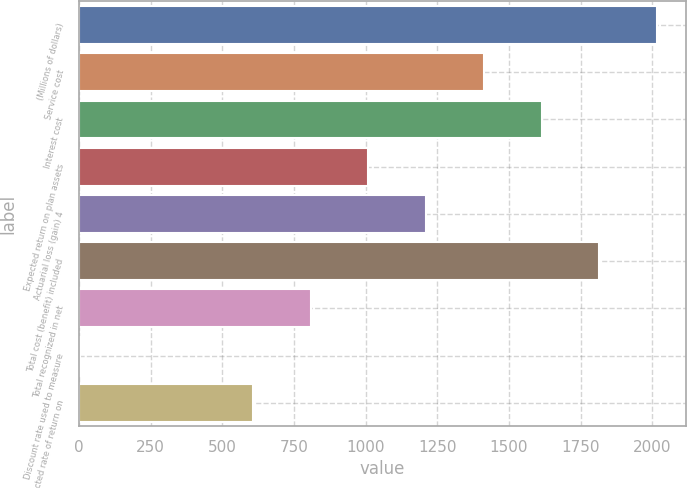<chart> <loc_0><loc_0><loc_500><loc_500><bar_chart><fcel>(Millions of dollars)<fcel>Service cost<fcel>Interest cost<fcel>Expected return on plan assets<fcel>Actuarial loss (gain) 4<fcel>Total cost (benefit) included<fcel>Total recognized in net<fcel>Discount rate used to measure<fcel>Expected rate of return on<nl><fcel>2016<fcel>1412.19<fcel>1613.46<fcel>1009.65<fcel>1210.92<fcel>1814.73<fcel>808.38<fcel>3.3<fcel>607.11<nl></chart> 